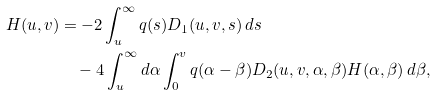<formula> <loc_0><loc_0><loc_500><loc_500>H ( u , v ) & = - 2 \int _ { u } ^ { \infty } q ( s ) D _ { 1 } ( u , v , s ) \, d s \\ & \quad - 4 \int _ { u } ^ { \infty } d \alpha \int _ { 0 } ^ { v } q ( \alpha - \beta ) D _ { 2 } ( u , v , \alpha , \beta ) H ( \alpha , \beta ) \, d \beta ,</formula> 